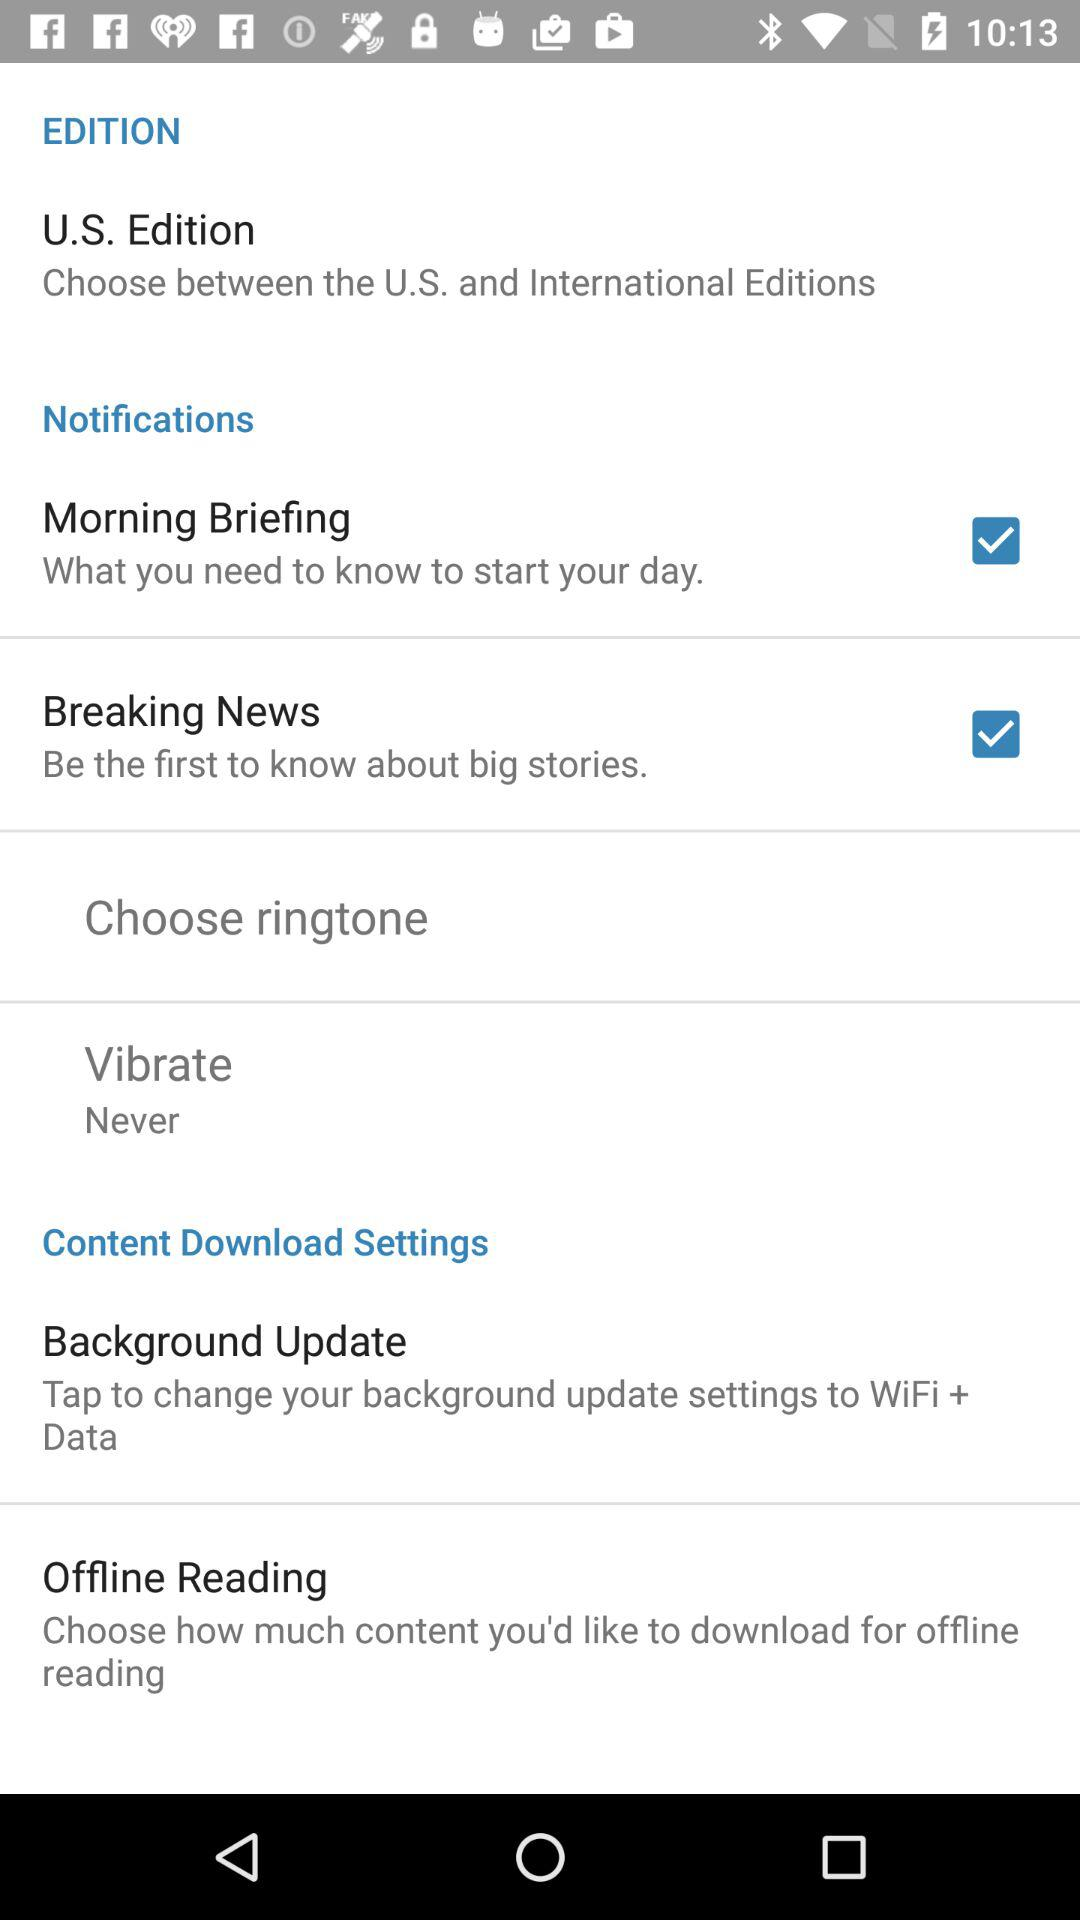What is the status of the "Morning Briefing"? The status is "on". 